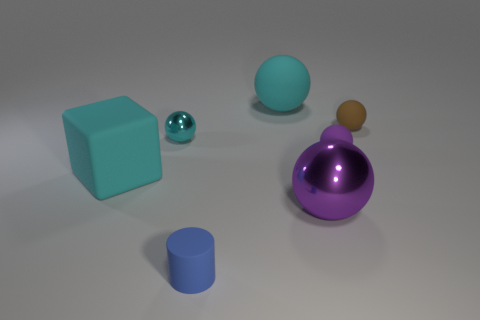Subtract 2 balls. How many balls are left? 3 Subtract all gray spheres. Subtract all blue cubes. How many spheres are left? 5 Add 3 cyan cubes. How many objects exist? 10 Subtract all cubes. How many objects are left? 6 Subtract 1 brown spheres. How many objects are left? 6 Subtract all blue things. Subtract all blue things. How many objects are left? 5 Add 6 tiny cylinders. How many tiny cylinders are left? 7 Add 6 small cyan shiny things. How many small cyan shiny things exist? 7 